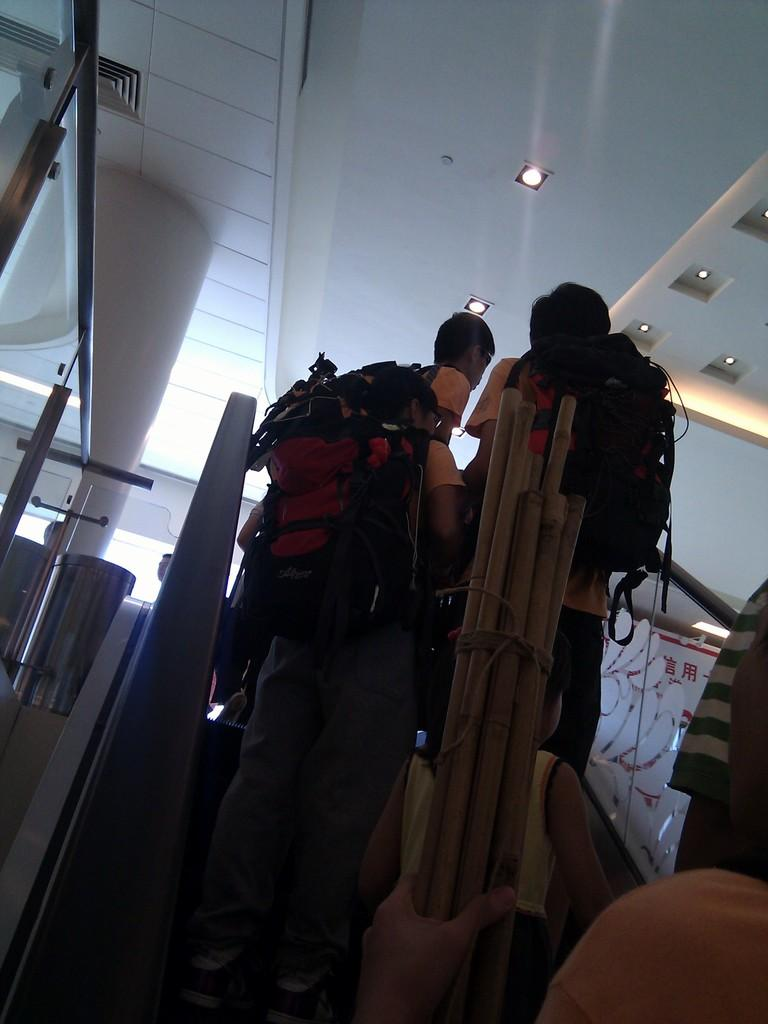What are the people in the image doing? The people in the image are standing on an escalator. What can be seen at the top of the escalator? There are ceiling lights at the top of the escalator. How many tomatoes are being carried by the people on the escalator? There is no mention of tomatoes in the image, so it cannot be determined how many tomatoes the people might be carrying. 